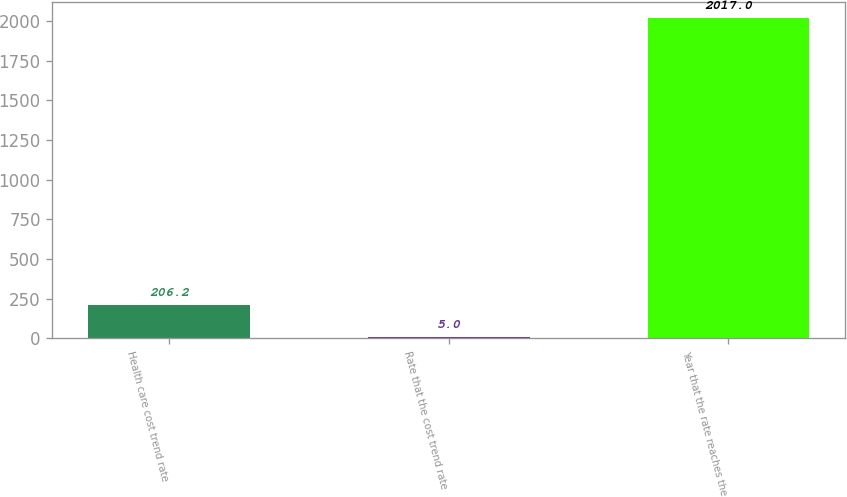<chart> <loc_0><loc_0><loc_500><loc_500><bar_chart><fcel>Health care cost trend rate<fcel>Rate that the cost trend rate<fcel>Year that the rate reaches the<nl><fcel>206.2<fcel>5<fcel>2017<nl></chart> 